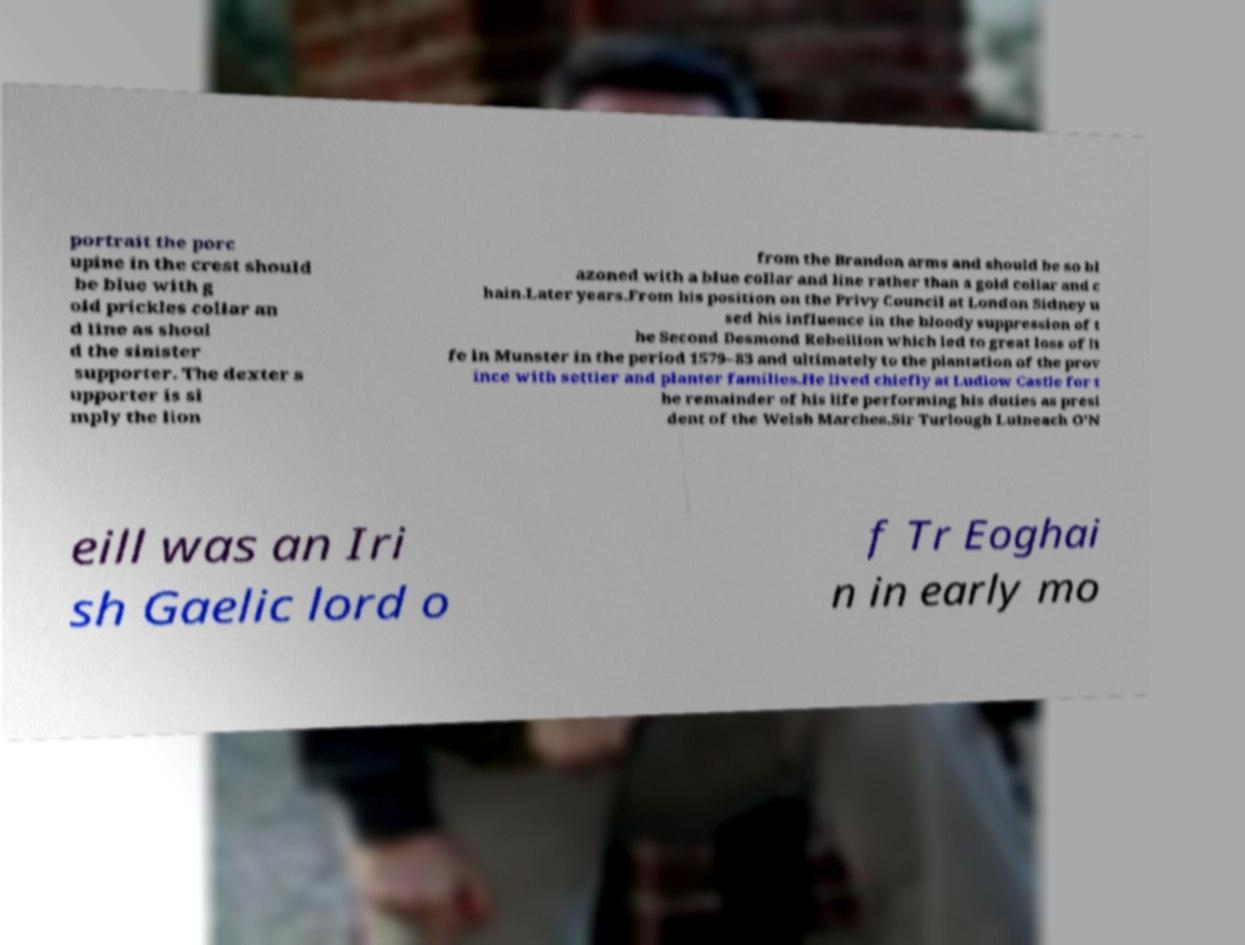Could you extract and type out the text from this image? portrait the porc upine in the crest should be blue with g old prickles collar an d line as shoul d the sinister supporter. The dexter s upporter is si mply the lion from the Brandon arms and should be so bl azoned with a blue collar and line rather than a gold collar and c hain.Later years.From his position on the Privy Council at London Sidney u sed his influence in the bloody suppression of t he Second Desmond Rebellion which led to great loss of li fe in Munster in the period 1579–83 and ultimately to the plantation of the prov ince with settler and planter families.He lived chiefly at Ludlow Castle for t he remainder of his life performing his duties as presi dent of the Welsh Marches.Sir Turlough Luineach O'N eill was an Iri sh Gaelic lord o f Tr Eoghai n in early mo 